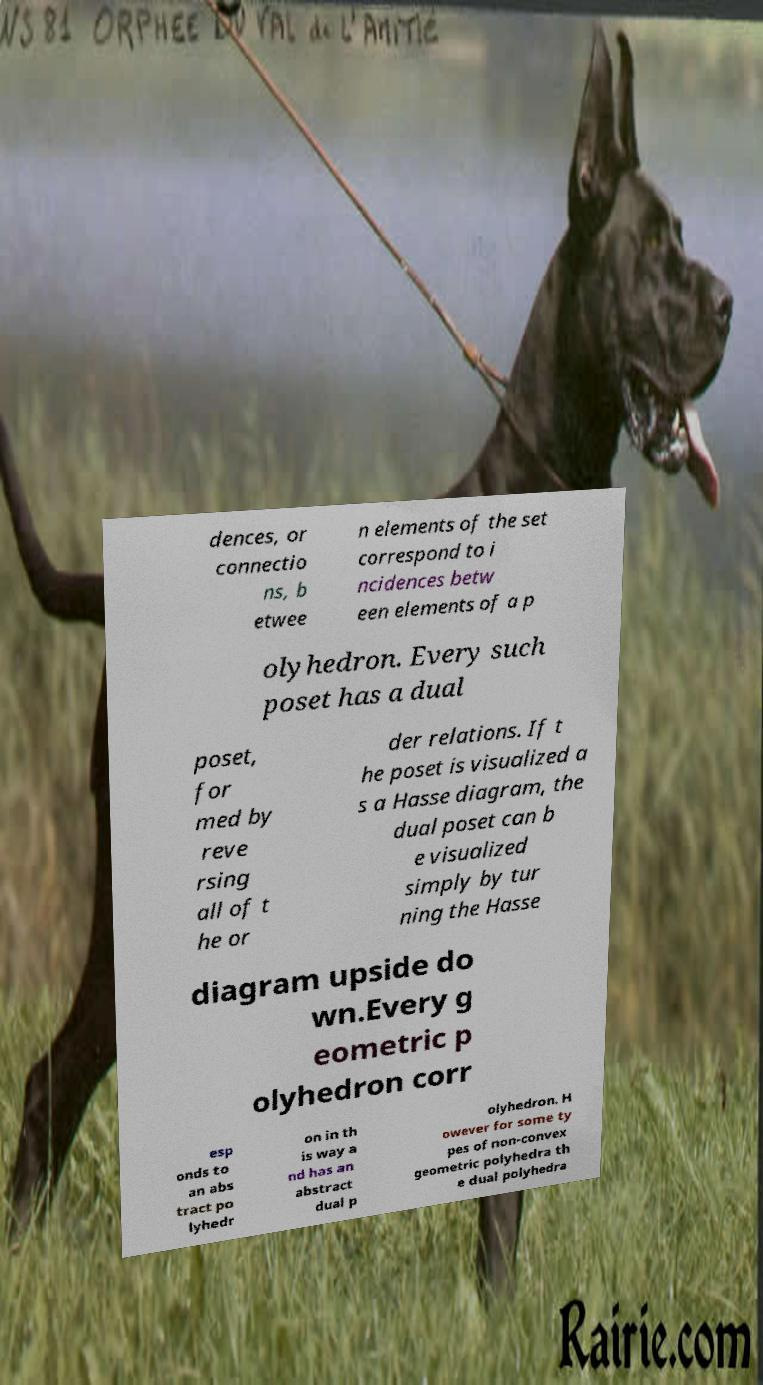For documentation purposes, I need the text within this image transcribed. Could you provide that? dences, or connectio ns, b etwee n elements of the set correspond to i ncidences betw een elements of a p olyhedron. Every such poset has a dual poset, for med by reve rsing all of t he or der relations. If t he poset is visualized a s a Hasse diagram, the dual poset can b e visualized simply by tur ning the Hasse diagram upside do wn.Every g eometric p olyhedron corr esp onds to an abs tract po lyhedr on in th is way a nd has an abstract dual p olyhedron. H owever for some ty pes of non-convex geometric polyhedra th e dual polyhedra 